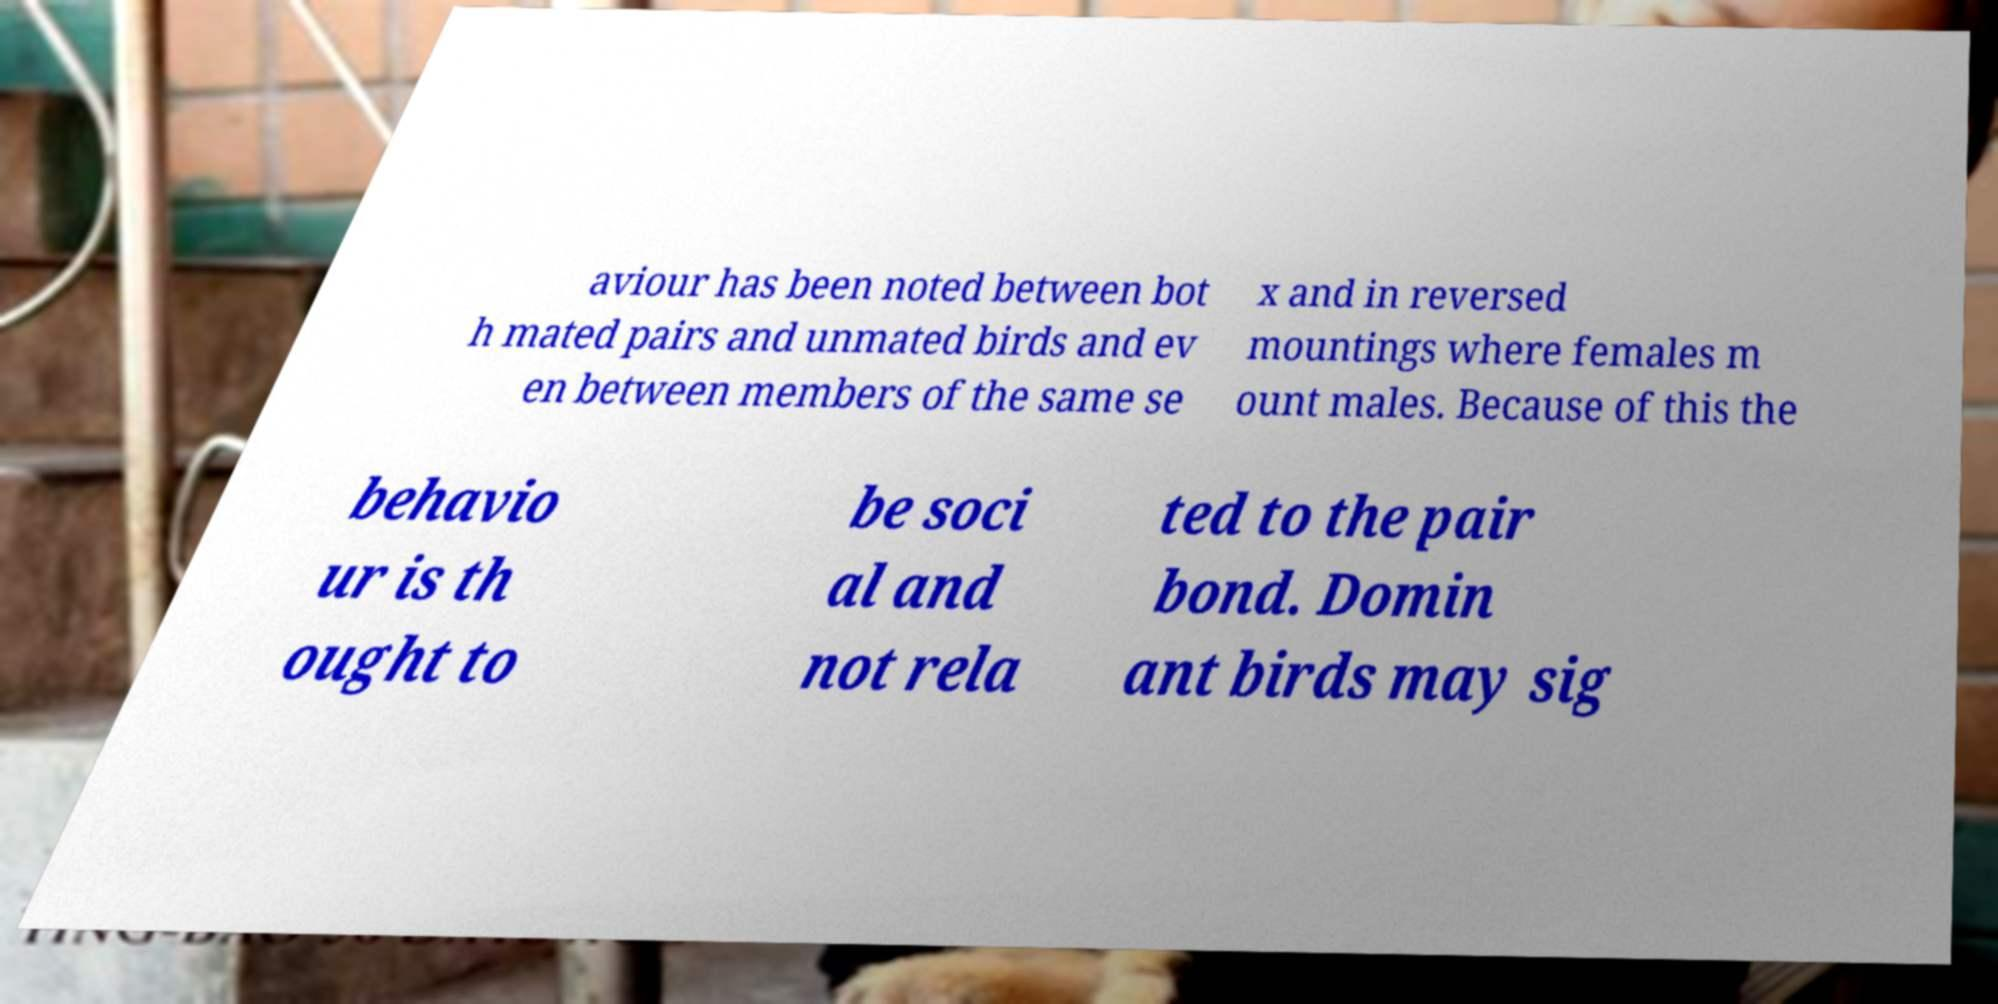Can you explain the significance of the behavior mentioned in this text about birds? The text on the image discusses intriguing aspects of bird behavior noting that actions such as reversed mountings and the same-sex interactions might be social rather than being strictly related to reproduction. This challenges common perceptions and is significant in understanding broader social structures among birds. 